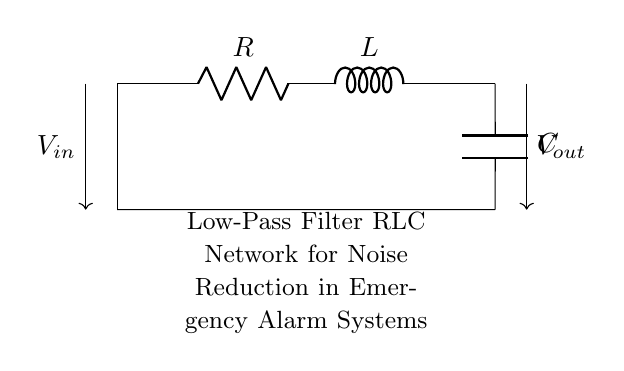What type of filter is represented by this circuit? The circuit diagram illustrates a low-pass filter configuration, which allows low-frequency signals to pass while attenuating high-frequency signals. This determination comes from the arrangement of the resistor, inductor, and capacitor.
Answer: Low-pass filter What components are in this RLC network? The components in the network include a resistor (R), an inductor (L), and a capacitor (C). This can be identified by their respective labels and positions on the diagram.
Answer: Resistor, Inductor, Capacitor What is the input voltage denoted in the diagram? The input voltage is represented by the symbol V_in indicated on the circuit diagram, shown as an arrow entering the circuit before the resistor.
Answer: V_in What effect does the inductor have in this circuit? The inductor in this circuit provides impedance to rapid changes in current, effectively filtering out high-frequency noise. Its role is vital in distinguishing between high and low frequencies in the signal.
Answer: Attenuates high-frequency noise Which component affects low-frequency signals the most? The capacitor has the most significant effect on low-frequency signals, as it allows them to pass through while charging and discharging, thus having a filtering action on high frequencies.
Answer: Capacitor What is the configuration direction of the output voltage? The output voltage is directed out of the circuit represented by the label V_out and indicated by an arrow pointing to the right, showing where the filtered signal is taken from.
Answer: V_out What is the significance of the low-pass filter in emergency alarm systems? The low-pass filter reduces noise from high-frequency signals, ensuring that the important low-frequency alarm signals are clearly heard. This noise reduction is crucial for the effective operation of alarm systems in emergencies.
Answer: Noise reduction 